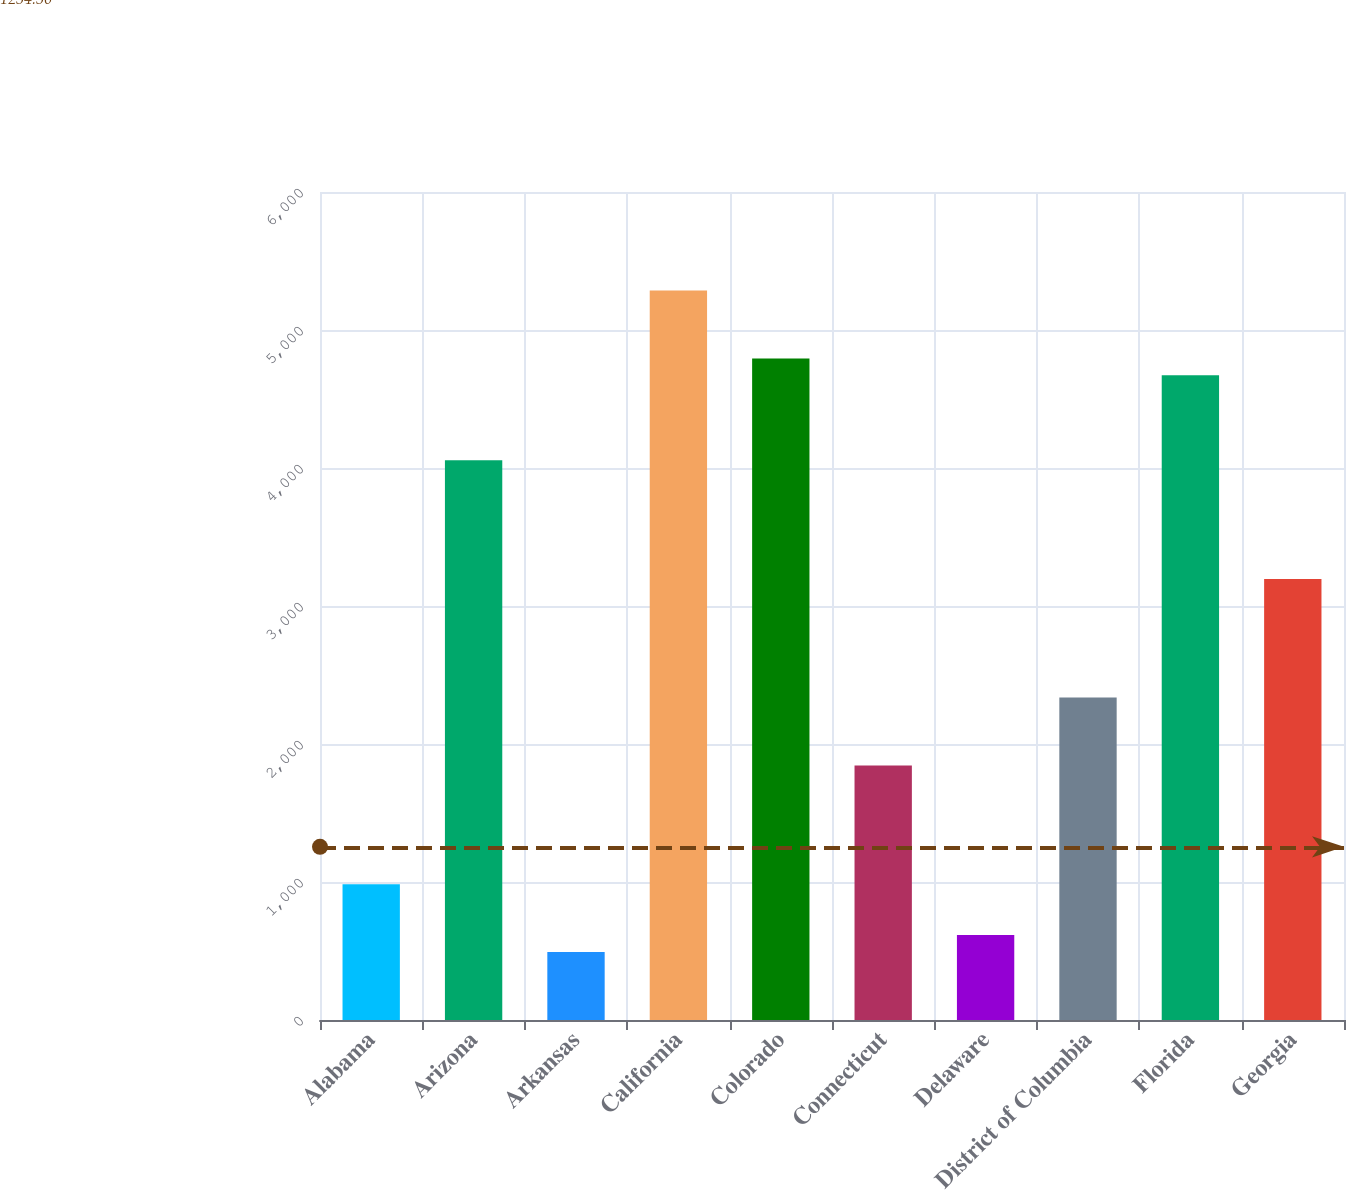Convert chart. <chart><loc_0><loc_0><loc_500><loc_500><bar_chart><fcel>Alabama<fcel>Arizona<fcel>Arkansas<fcel>California<fcel>Colorado<fcel>Connecticut<fcel>Delaware<fcel>District of Columbia<fcel>Florida<fcel>Georgia<nl><fcel>984.2<fcel>4056.7<fcel>492.6<fcel>5285.7<fcel>4794.1<fcel>1844.5<fcel>615.5<fcel>2336.1<fcel>4671.2<fcel>3196.4<nl></chart> 